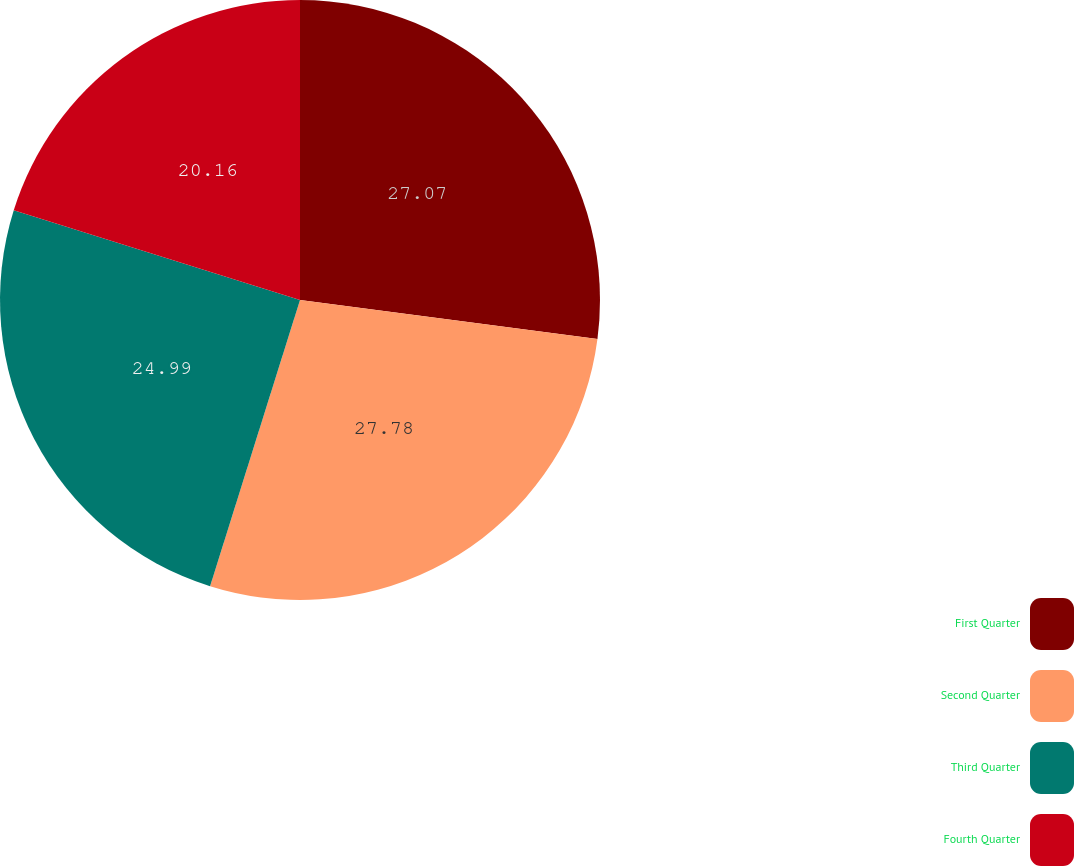<chart> <loc_0><loc_0><loc_500><loc_500><pie_chart><fcel>First Quarter<fcel>Second Quarter<fcel>Third Quarter<fcel>Fourth Quarter<nl><fcel>27.07%<fcel>27.77%<fcel>24.99%<fcel>20.16%<nl></chart> 